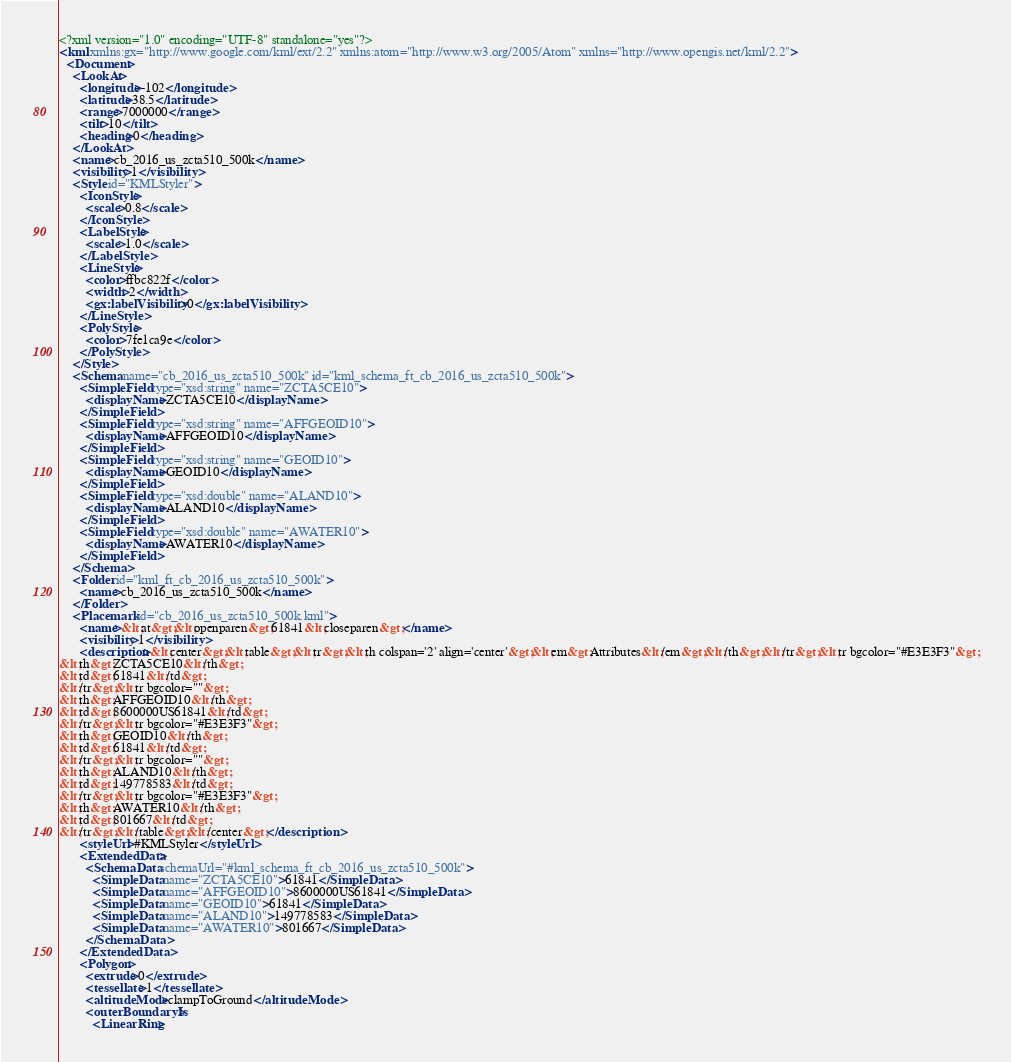Convert code to text. <code><loc_0><loc_0><loc_500><loc_500><_XML_><?xml version="1.0" encoding="UTF-8" standalone="yes"?>
<kml xmlns:gx="http://www.google.com/kml/ext/2.2" xmlns:atom="http://www.w3.org/2005/Atom" xmlns="http://www.opengis.net/kml/2.2">
  <Document>
    <LookAt>
      <longitude>-102</longitude>
      <latitude>38.5</latitude>
      <range>7000000</range>
      <tilt>10</tilt>
      <heading>0</heading>
    </LookAt>
    <name>cb_2016_us_zcta510_500k</name>
    <visibility>1</visibility>
    <Style id="KMLStyler">
      <IconStyle>
        <scale>0.8</scale>
      </IconStyle>
      <LabelStyle>
        <scale>1.0</scale>
      </LabelStyle>
      <LineStyle>
        <color>ffbc822f</color>
        <width>2</width>
        <gx:labelVisibility>0</gx:labelVisibility>
      </LineStyle>
      <PolyStyle>
        <color>7fe1ca9e</color>
      </PolyStyle>
    </Style>
    <Schema name="cb_2016_us_zcta510_500k" id="kml_schema_ft_cb_2016_us_zcta510_500k">
      <SimpleField type="xsd:string" name="ZCTA5CE10">
        <displayName>ZCTA5CE10</displayName>
      </SimpleField>
      <SimpleField type="xsd:string" name="AFFGEOID10">
        <displayName>AFFGEOID10</displayName>
      </SimpleField>
      <SimpleField type="xsd:string" name="GEOID10">
        <displayName>GEOID10</displayName>
      </SimpleField>
      <SimpleField type="xsd:double" name="ALAND10">
        <displayName>ALAND10</displayName>
      </SimpleField>
      <SimpleField type="xsd:double" name="AWATER10">
        <displayName>AWATER10</displayName>
      </SimpleField>
    </Schema>
    <Folder id="kml_ft_cb_2016_us_zcta510_500k">
      <name>cb_2016_us_zcta510_500k</name>
    </Folder>
    <Placemark id="cb_2016_us_zcta510_500k.kml">
      <name>&lt;at&gt;&lt;openparen&gt;61841&lt;closeparen&gt;</name>
      <visibility>1</visibility>
      <description>&lt;center&gt;&lt;table&gt;&lt;tr&gt;&lt;th colspan='2' align='center'&gt;&lt;em&gt;Attributes&lt;/em&gt;&lt;/th&gt;&lt;/tr&gt;&lt;tr bgcolor="#E3E3F3"&gt;
&lt;th&gt;ZCTA5CE10&lt;/th&gt;
&lt;td&gt;61841&lt;/td&gt;
&lt;/tr&gt;&lt;tr bgcolor=""&gt;
&lt;th&gt;AFFGEOID10&lt;/th&gt;
&lt;td&gt;8600000US61841&lt;/td&gt;
&lt;/tr&gt;&lt;tr bgcolor="#E3E3F3"&gt;
&lt;th&gt;GEOID10&lt;/th&gt;
&lt;td&gt;61841&lt;/td&gt;
&lt;/tr&gt;&lt;tr bgcolor=""&gt;
&lt;th&gt;ALAND10&lt;/th&gt;
&lt;td&gt;149778583&lt;/td&gt;
&lt;/tr&gt;&lt;tr bgcolor="#E3E3F3"&gt;
&lt;th&gt;AWATER10&lt;/th&gt;
&lt;td&gt;801667&lt;/td&gt;
&lt;/tr&gt;&lt;/table&gt;&lt;/center&gt;</description>
      <styleUrl>#KMLStyler</styleUrl>
      <ExtendedData>
        <SchemaData schemaUrl="#kml_schema_ft_cb_2016_us_zcta510_500k">
          <SimpleData name="ZCTA5CE10">61841</SimpleData>
          <SimpleData name="AFFGEOID10">8600000US61841</SimpleData>
          <SimpleData name="GEOID10">61841</SimpleData>
          <SimpleData name="ALAND10">149778583</SimpleData>
          <SimpleData name="AWATER10">801667</SimpleData>
        </SchemaData>
      </ExtendedData>
      <Polygon>
        <extrude>0</extrude>
        <tessellate>1</tessellate>
        <altitudeMode>clampToGround</altitudeMode>
        <outerBoundaryIs>
          <LinearRing></code> 